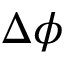Convert formula to latex. <formula><loc_0><loc_0><loc_500><loc_500>\Delta \phi</formula> 